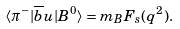Convert formula to latex. <formula><loc_0><loc_0><loc_500><loc_500>\langle \pi ^ { - } | \overline { b } u | B ^ { 0 } \rangle = m _ { B } F _ { s } ( q ^ { 2 } ) .</formula> 